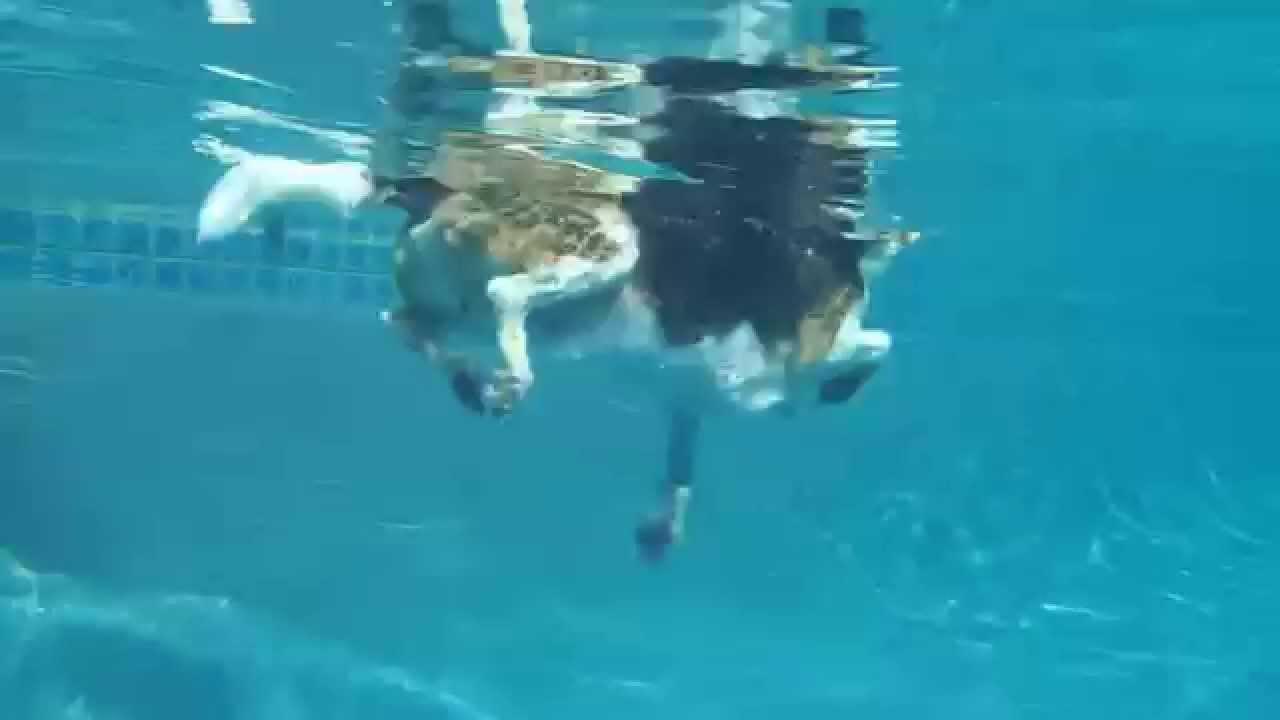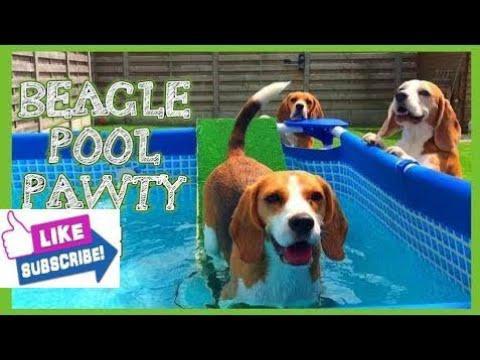The first image is the image on the left, the second image is the image on the right. Considering the images on both sides, is "A person is visible in a pool that also has a dog in it." valid? Answer yes or no. No. The first image is the image on the left, the second image is the image on the right. For the images shown, is this caption "There are two dogs in total." true? Answer yes or no. No. 